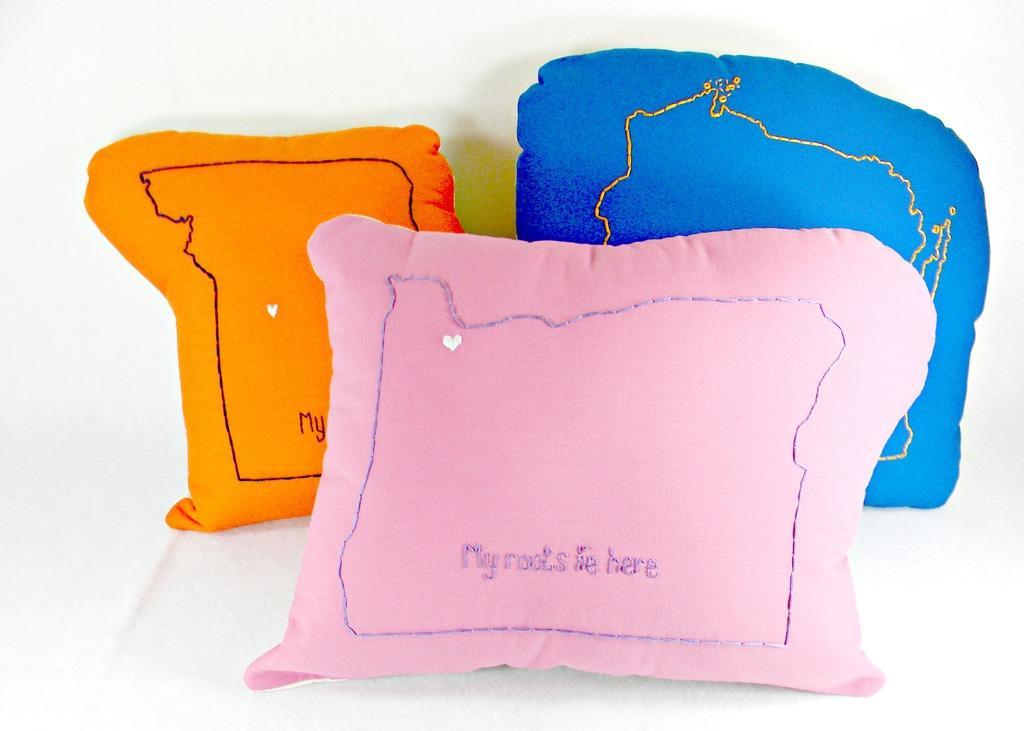In one or two sentences, can you explain what this image depicts? In this image, we can see cushions with embroidery work on the white surface. 